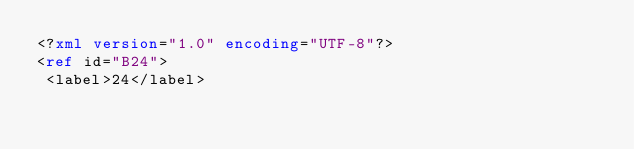Convert code to text. <code><loc_0><loc_0><loc_500><loc_500><_XML_><?xml version="1.0" encoding="UTF-8"?>
<ref id="B24">
 <label>24</label></code> 